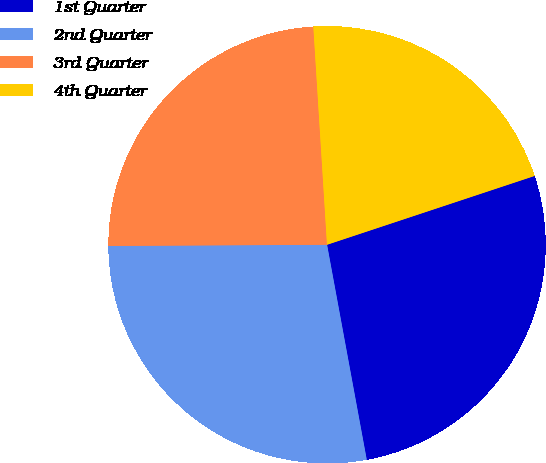<chart> <loc_0><loc_0><loc_500><loc_500><pie_chart><fcel>1st Quarter<fcel>2nd Quarter<fcel>3rd Quarter<fcel>4th Quarter<nl><fcel>27.19%<fcel>27.82%<fcel>24.09%<fcel>20.9%<nl></chart> 